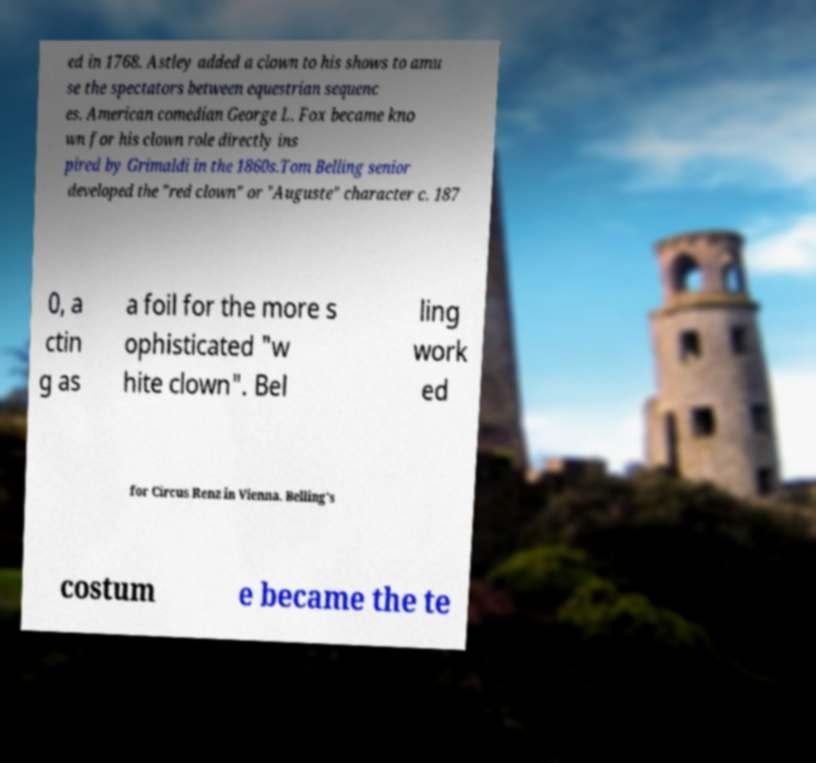I need the written content from this picture converted into text. Can you do that? ed in 1768. Astley added a clown to his shows to amu se the spectators between equestrian sequenc es. American comedian George L. Fox became kno wn for his clown role directly ins pired by Grimaldi in the 1860s.Tom Belling senior developed the "red clown" or "Auguste" character c. 187 0, a ctin g as a foil for the more s ophisticated "w hite clown". Bel ling work ed for Circus Renz in Vienna. Belling's costum e became the te 